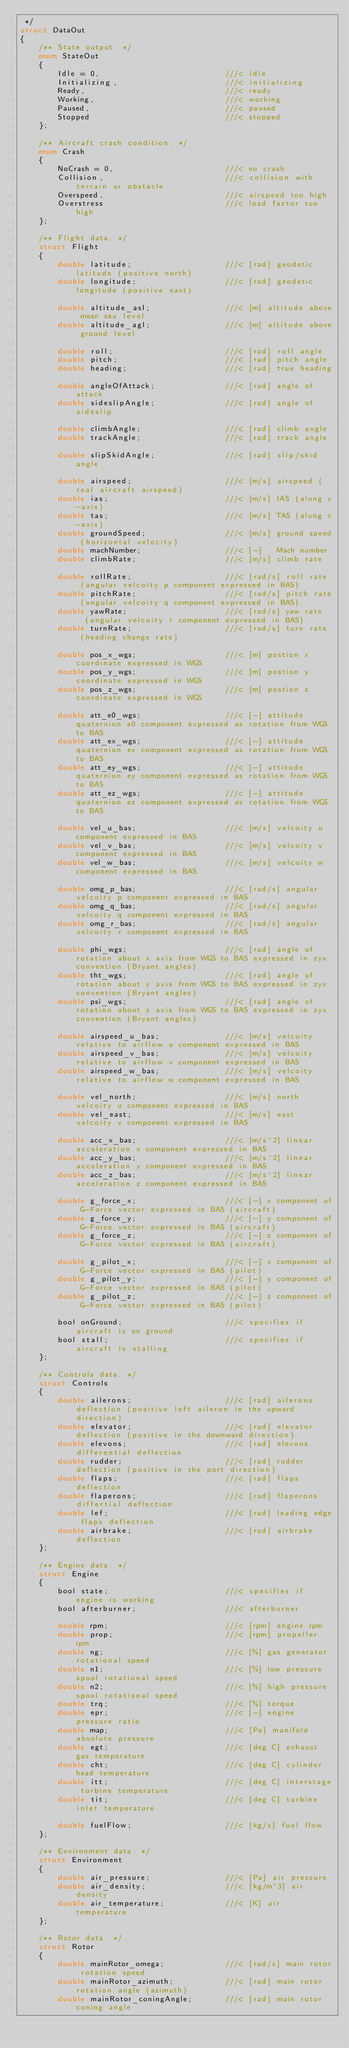<code> <loc_0><loc_0><loc_500><loc_500><_C_> */
struct DataOut
{
    /** State output. */
    enum StateOut
    {
        Idle = 0,                           ///< idle
        Initializing,                       ///< initializing
        Ready,                              ///< ready
        Working,                            ///< working
        Paused,                             ///< paused
        Stopped                             ///< stopped
    };

    /** Aircraft crash condition. */
    enum Crash
    {
        NoCrash = 0,                        ///< no crash
        Collision,                          ///< collision with terrain or obstacle
        Overspeed,                          ///< airspeed too high
        Overstress                          ///< load factor too high
    };

    /** Flight data. */
    struct Flight
    {
        double latitude;                    ///< [rad] geodetic latitude (positive north)
        double longitude;                   ///< [rad] geodetic longitude (positive east)

        double altitude_asl;                ///< [m] altitude above mean sea level
        double altitude_agl;                ///< [m] altitude above ground level

        double roll;                        ///< [rad] roll angle
        double pitch;                       ///< [rad] pitch angle
        double heading;                     ///< [rad] true heading

        double angleOfAttack;               ///< [rad] angle of attack
        double sideslipAngle;               ///< [rad] angle of sideslip

        double climbAngle;                  ///< [rad] climb angle
        double trackAngle;                  ///< [rad] track angle

        double slipSkidAngle;               ///< [rad] slip/skid angle

        double airspeed;                    ///< [m/s] airspeed (real aircraft airspeed)
        double ias;                         ///< [m/s] IAS (along x-axis)
        double tas;                         ///< [m/s] TAS (along x-axis)
        double groundSpeed;                 ///< [m/s] ground speed (horizontal velocity)
        double machNumber;                  ///< [-]   Mach number
        double climbRate;                   ///< [m/s] climb rate

        double rollRate;                    ///< [rad/s] roll rate  (angular velcoity p component expressed in BAS)
        double pitchRate;                   ///< [rad/s] pitch rate (angular velcoity q component expressed in BAS)
        double yawRate;                     ///< [rad/s] yaw rate   (angular velcoity r component expressed in BAS)
        double turnRate;                    ///< [rad/s] turn rate  (heading change rate)

        double pos_x_wgs;                   ///< [m] postion x coordinate expressed in WGS
        double pos_y_wgs;                   ///< [m] postion y coordinate expressed in WGS
        double pos_z_wgs;                   ///< [m] postion z coordinate expressed in WGS

        double att_e0_wgs;                  ///< [-] attitude quaternion e0 component expressed as rotation from WGS to BAS
        double att_ex_wgs;                  ///< [-] attitude quaternion ex component expressed as rotation from WGS to BAS
        double att_ey_wgs;                  ///< [-] attitude quaternion ey component expressed as rotation from WGS to BAS
        double att_ez_wgs;                  ///< [-] attitude quaternion ez component expressed as rotation from WGS to BAS

        double vel_u_bas;                   ///< [m/s] velcoity u component expressed in BAS
        double vel_v_bas;                   ///< [m/s] velcoity v component expressed in BAS
        double vel_w_bas;                   ///< [m/s] velcoity w component expressed in BAS

        double omg_p_bas;                   ///< [rad/s] angular velcoity p component expressed in BAS
        double omg_q_bas;                   ///< [rad/s] angular velcoity q component expressed in BAS
        double omg_r_bas;                   ///< [rad/s] angular velcoity r component expressed in BAS

        double phi_wgs;                     ///< [rad] angle of rotation about x axis from WGS to BAS expressed in zyx convention (Bryant angles)
        double tht_wgs;                     ///< [rad] angle of rotation about y axis from WGS to BAS expressed in zyx convention (Bryant angles)
        double psi_wgs;                     ///< [rad] angle of rotation about z axis from WGS to BAS expressed in zyx convention (Bryant angles)

        double airspeed_u_bas;              ///< [m/s] velcoity relative to airflow u component expressed in BAS
        double airspeed_v_bas;              ///< [m/s] velcoity relative to airflow v component expressed in BAS
        double airspeed_w_bas;              ///< [m/s] velcoity relative to airflow w component expressed in BAS

        double vel_north;                   ///< [m/s] north velcoity u component expressed in BAS
        double vel_east;                    ///< [m/s] east velcoity v component expressed in BAS

        double acc_x_bas;                   ///< [m/s^2] linear acceleration x component expressed in BAS
        double acc_y_bas;                   ///< [m/s^2] linear acceleration y component expressed in BAS
        double acc_z_bas;                   ///< [m/s^2] linear acceleration z component expressed in BAS

        double g_force_x;                   ///< [-] x component of G-Force vector expressed in BAS (aircraft)
        double g_force_y;                   ///< [-] y component of G-Force vector expressed in BAS (aircraft)
        double g_force_z;                   ///< [-] z component of G-Force vector expressed in BAS (aircraft)

        double g_pilot_x;                   ///< [-] x component of G-Force vector expressed in BAS (pilot)
        double g_pilot_y;                   ///< [-] y component of G-Force vector expressed in BAS (pilot)
        double g_pilot_z;                   ///< [-] z component of G-Force vector expressed in BAS (pilot)

        bool onGround;                      ///< specifies if aircraft is on ground
        bool stall;                         ///< specifies if aircraft is stalling
    };

    /** Controls data. */
    struct Controls
    {
        double ailerons;                    ///< [rad] ailerons deflection (positive left aileron in the upward direction)
        double elevator;                    ///< [rad] elevator deflection (positive in the downward direction)
        double elevons;                     ///< [rad] elevons differential deflection
        double rudder;                      ///< [rad] rudder deflection (positive in the port direction)
        double flaps;                       ///< [rad] flaps deflection
        double flaperons;                   ///< [rad] flaperons differtial deflection
        double lef;                         ///< [rad] leading edge flaps deflection
        double airbrake;                    ///< [rad] airbrake deflection
    };

    /** Engine data. */
    struct Engine
    {
        bool state;                         ///< specifies if engine is working
        bool afterburner;                   ///< afterburner

        double rpm;                         ///< [rpm] engine rpm
        double prop;                        ///< [rpm] propeller rpm
        double ng;                          ///< [%] gas generator rotational speed
        double n1;                          ///< [%] low pressure spool rotational speed
        double n2;                          ///< [%] high pressure spool rotational speed
        double trq;                         ///< [%] torque
        double epr;                         ///< [-] engine pressure ratio
        double map;                         ///< [Pa] manifold absolute pressure
        double egt;                         ///< [deg C] exhaust gas temperature
        double cht;                         ///< [deg C] cylinder head temperature
        double itt;                         ///< [deg C] interstage turbine temperature
        double tit;                         ///< [deg C] turbine inlet temperature

        double fuelFlow;                    ///< [kg/s] fuel flow
    };

    /** Environment data. */
    struct Environment
    {
        double air_pressure;                ///< [Pa] air pressure
        double air_density;                 ///< [kg/m^3] air density
        double air_temperature;             ///< [K] air temperature
    };

    /** Rotor data. */
    struct Rotor
    {
        double mainRotor_omega;             ///< [rad/s] main rotor rotation speed
        double mainRotor_azimuth;           ///< [rad] main rotor rotation angle (azimuth)
        double mainRotor_coningAngle;       ///< [rad] main rotor coning angle</code> 